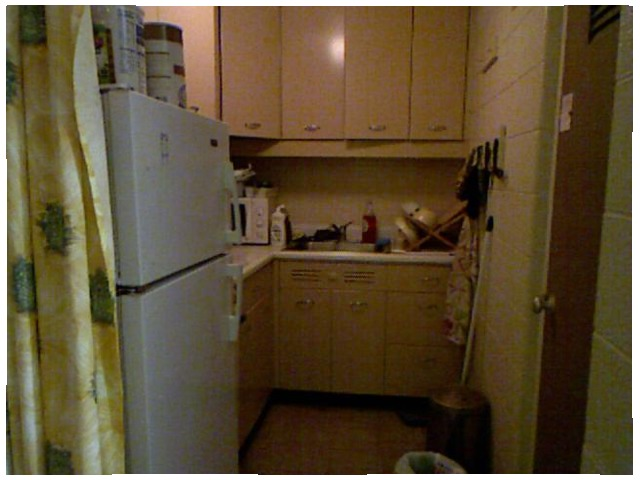<image>
Can you confirm if the fridge is in front of the curtain? No. The fridge is not in front of the curtain. The spatial positioning shows a different relationship between these objects. Where is the handle in relation to the microwave? Is it on the microwave? Yes. Looking at the image, I can see the handle is positioned on top of the microwave, with the microwave providing support. Is the curtain behind the fridge? No. The curtain is not behind the fridge. From this viewpoint, the curtain appears to be positioned elsewhere in the scene. 